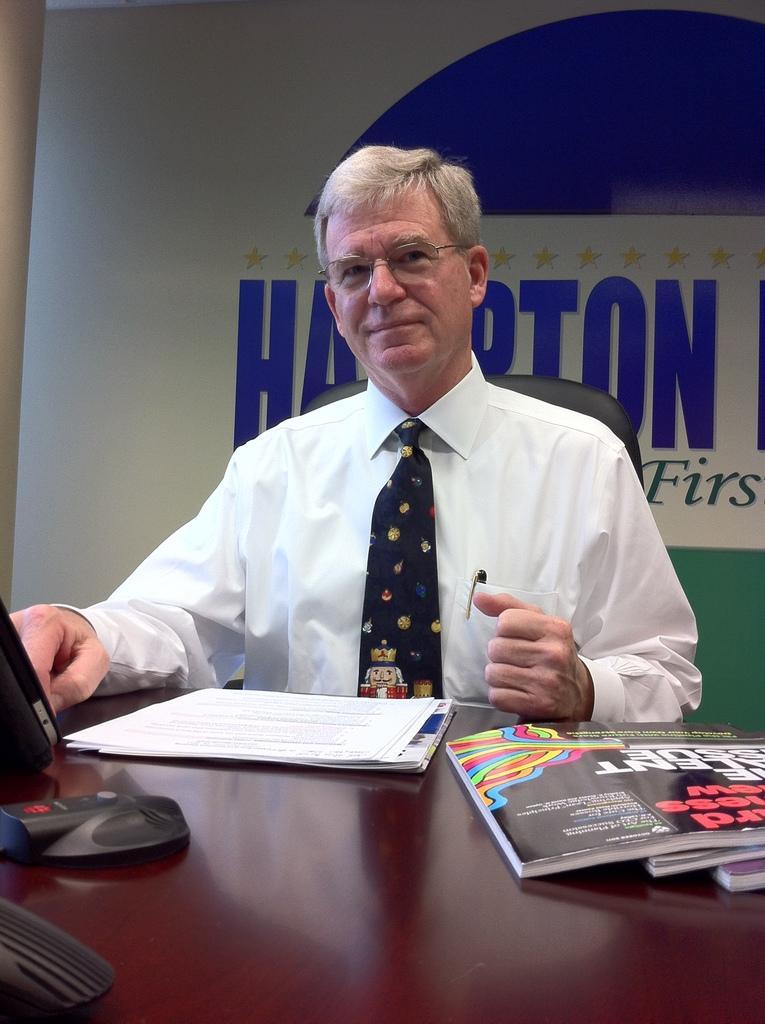In one or two sentences, can you explain what this image depicts? In this image I can see a person sitting in-front of the table. On the table there are books and papers. 